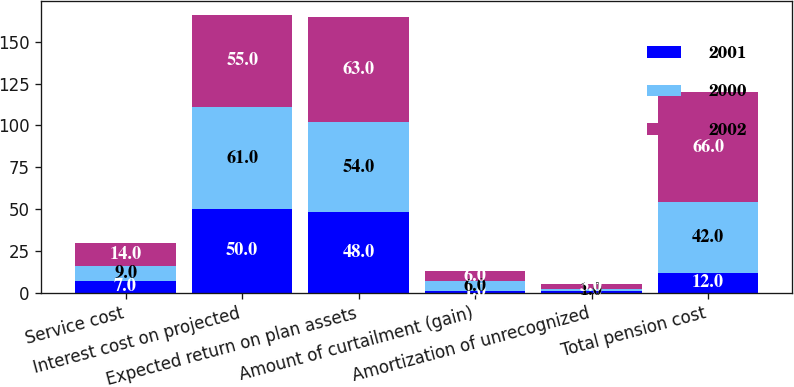Convert chart. <chart><loc_0><loc_0><loc_500><loc_500><stacked_bar_chart><ecel><fcel>Service cost<fcel>Interest cost on projected<fcel>Expected return on plan assets<fcel>Amount of curtailment (gain)<fcel>Amortization of unrecognized<fcel>Total pension cost<nl><fcel>2001<fcel>7<fcel>50<fcel>48<fcel>1<fcel>1<fcel>12<nl><fcel>2000<fcel>9<fcel>61<fcel>54<fcel>6<fcel>1<fcel>42<nl><fcel>2002<fcel>14<fcel>55<fcel>63<fcel>6<fcel>3<fcel>66<nl></chart> 